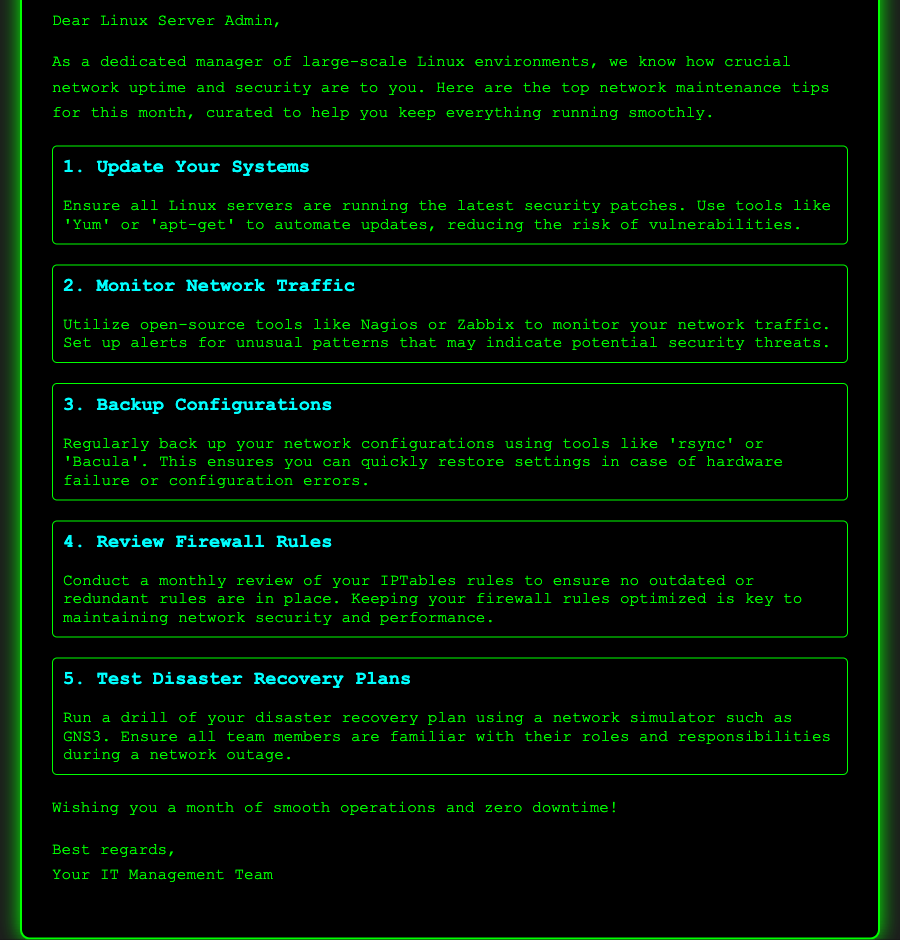What is the title of the document? The title is found in the header section and serves as the main topic of the document, which is "Top 5 Network Maintenance Tips for October."
Answer: Top 5 Network Maintenance Tips for October What is the first maintenance tip? The first tip is detailed in the list of tips provided in the document.
Answer: Update Your Systems How many tips are listed? The number of tips can be determined by counting the list items in the tips section.
Answer: 5 Which tool is suggested for monitoring network traffic? The document provides specific examples of tools in the relevant tip for monitoring network traffic.
Answer: Nagios What color is the background of the card? The background color of the card is specified in the style section of the document.
Answer: Black What month is the focus of these tips? The month is explicitly mentioned in the title at the top of the document.
Answer: October What should you regularly back up according to the tips? The document specifies what needs to be backed up in the relevant tip.
Answer: Network configurations What is the purpose of reviewing IPTables rules? The rationale for reviewing IPTables rules is outlined in the corresponding tip, explaining its importance.
Answer: Network security and performance Who is the greeting card addressed to? The recipient is indicated in the greeting section at the beginning of the document.
Answer: Linux Server Admin 